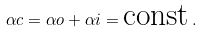Convert formula to latex. <formula><loc_0><loc_0><loc_500><loc_500>\alpha c = \alpha o + \alpha i = \text {const} \, .</formula> 